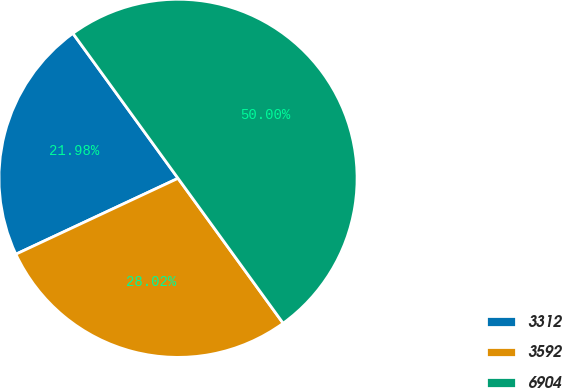<chart> <loc_0><loc_0><loc_500><loc_500><pie_chart><fcel>3312<fcel>3592<fcel>6904<nl><fcel>21.98%<fcel>28.02%<fcel>50.0%<nl></chart> 